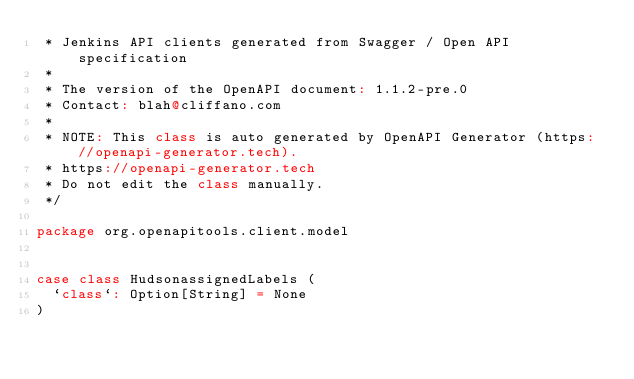<code> <loc_0><loc_0><loc_500><loc_500><_Scala_> * Jenkins API clients generated from Swagger / Open API specification
 *
 * The version of the OpenAPI document: 1.1.2-pre.0
 * Contact: blah@cliffano.com
 *
 * NOTE: This class is auto generated by OpenAPI Generator (https://openapi-generator.tech).
 * https://openapi-generator.tech
 * Do not edit the class manually.
 */

package org.openapitools.client.model


case class HudsonassignedLabels (
  `class`: Option[String] = None
)

</code> 